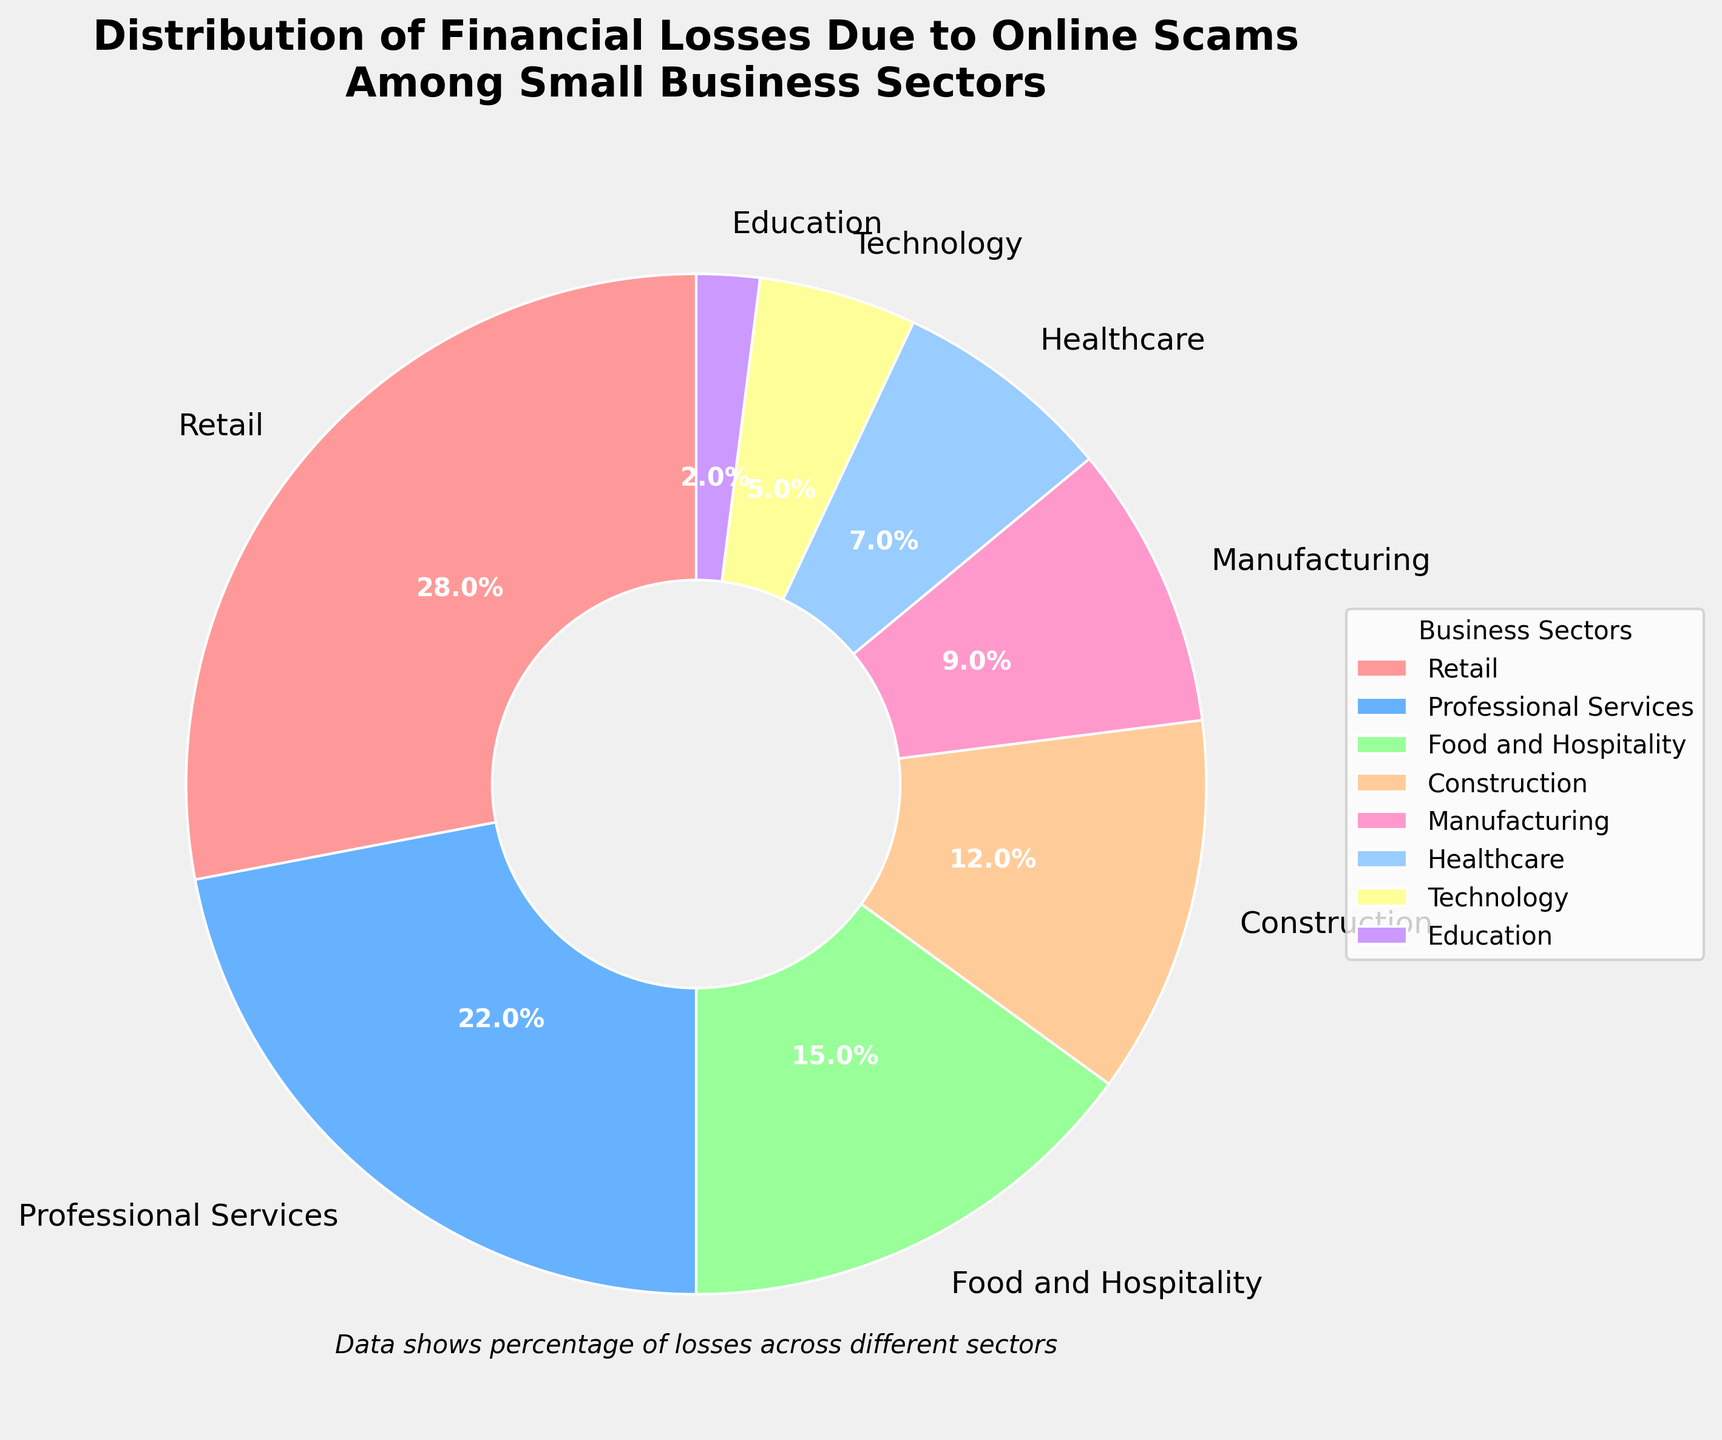What percentage of financial losses is attributed to the Retail sector? The percentage is directly labeled on the pie chart under the "Retail" section.
Answer: 28% Which sector accounts for the smallest share of financial losses? By looking at the smallest slice of the pie chart, labeled "Education," we can see it accounts for the smallest share of financial losses.
Answer: Education What is the combined percentage of financial losses for the Professional Services and Technology sectors? Add the percentages of Professional Services (22%) and Technology (5%) sectors together. 22% + 5% = 27%
Answer: 27% How much greater is the percentage of financial losses in the Retail sector compared to the Construction sector? Subtract the percentage of Construction (12%) from that of Retail (28%). 28% - 12% = 16%
Answer: 16% Which two sectors have almost the same share of financial losses, and what are their percentages? By looking at the pie chart, Manufacturing and Healthcare sectors have close shares, with Manufacturing at 9% and Healthcare at 7%.
Answer: Manufacturing (9%) and Healthcare (7%) What is the total percentage accounted for by sectors other than Retail, Professional Services, and Food and Hospitality? First, sum the percentages of Retail (28%), Professional Services (22%), and Food and Hospitality (15%). Then subtract this sum from 100%. 28% + 22% + 15% = 65%, and 100% - 65% = 35%
Answer: 35% What color represents the Food and Hospitality sector in the pie chart? Identify the color linked to the "Food and Hospitality" section. The slice is colored green (#99FF99).
Answer: Green Which sector has a larger percentage of financial losses: Healthcare or Technology? Compare the percentages of Healthcare (7%) and Technology (5%). Use the legend or labels for verification.
Answer: Healthcare How do the financial losses in the Manufacturing sector compare to those in the Construction sector? Compare the percentages: Manufacturing is 9%, and Construction is 12%. Construction has a higher percentage by 3%.
Answer: Construction What visual trait differentiates the Training/Education sector from the others the most? The Education sector not only has the smallest slice but also is the only one that stands out at just 2%, significantly different from the others.
Answer: Smallest slice 